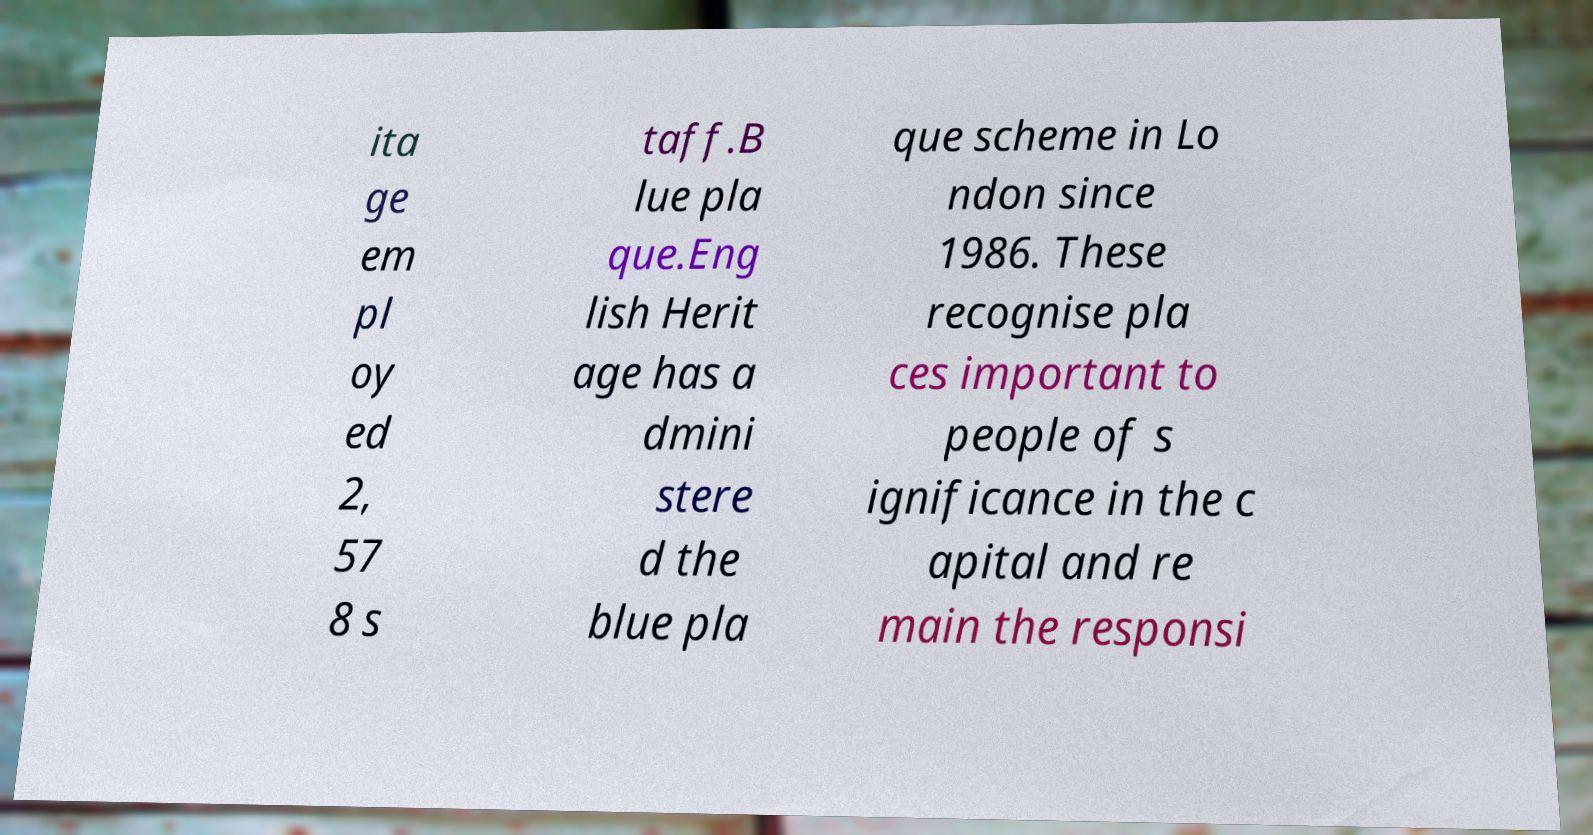Please identify and transcribe the text found in this image. ita ge em pl oy ed 2, 57 8 s taff.B lue pla que.Eng lish Herit age has a dmini stere d the blue pla que scheme in Lo ndon since 1986. These recognise pla ces important to people of s ignificance in the c apital and re main the responsi 